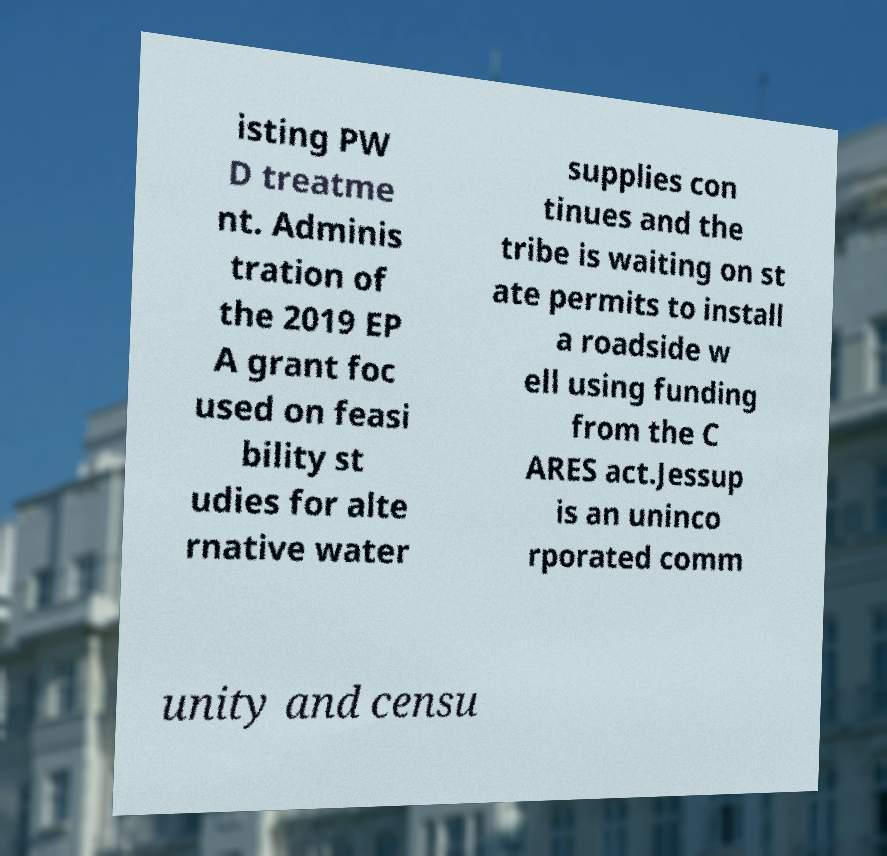I need the written content from this picture converted into text. Can you do that? isting PW D treatme nt. Adminis tration of the 2019 EP A grant foc used on feasi bility st udies for alte rnative water supplies con tinues and the tribe is waiting on st ate permits to install a roadside w ell using funding from the C ARES act.Jessup is an uninco rporated comm unity and censu 